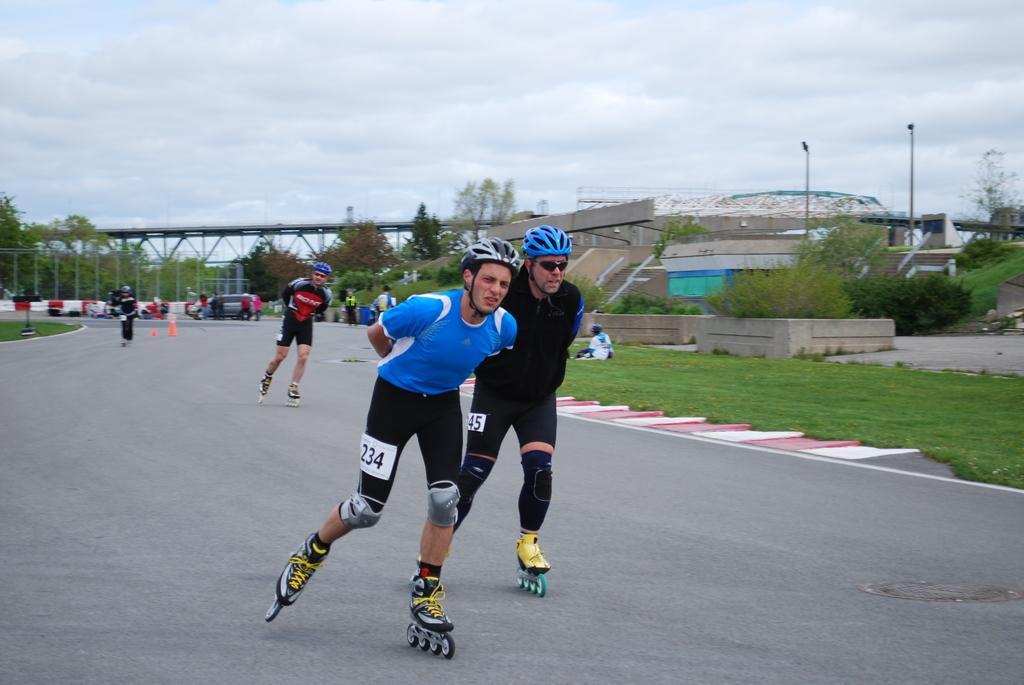Could you give a brief overview of what you see in this image? In this image I can see few persons wearing helmets on their heads and skating on the road. On both sides of the road, I can see the grass. In the background there are many trees, poles and buildings. On the left side there is a bridge. At the top of the image, I can see the sky and clouds. 